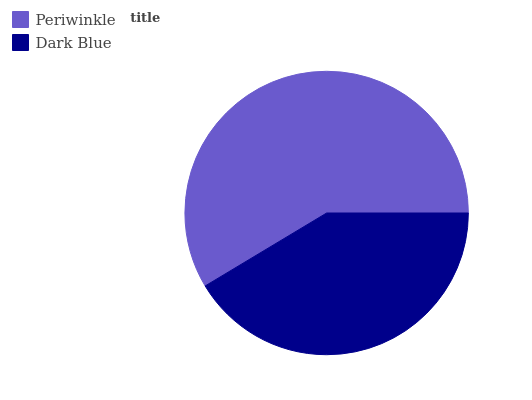Is Dark Blue the minimum?
Answer yes or no. Yes. Is Periwinkle the maximum?
Answer yes or no. Yes. Is Dark Blue the maximum?
Answer yes or no. No. Is Periwinkle greater than Dark Blue?
Answer yes or no. Yes. Is Dark Blue less than Periwinkle?
Answer yes or no. Yes. Is Dark Blue greater than Periwinkle?
Answer yes or no. No. Is Periwinkle less than Dark Blue?
Answer yes or no. No. Is Periwinkle the high median?
Answer yes or no. Yes. Is Dark Blue the low median?
Answer yes or no. Yes. Is Dark Blue the high median?
Answer yes or no. No. Is Periwinkle the low median?
Answer yes or no. No. 